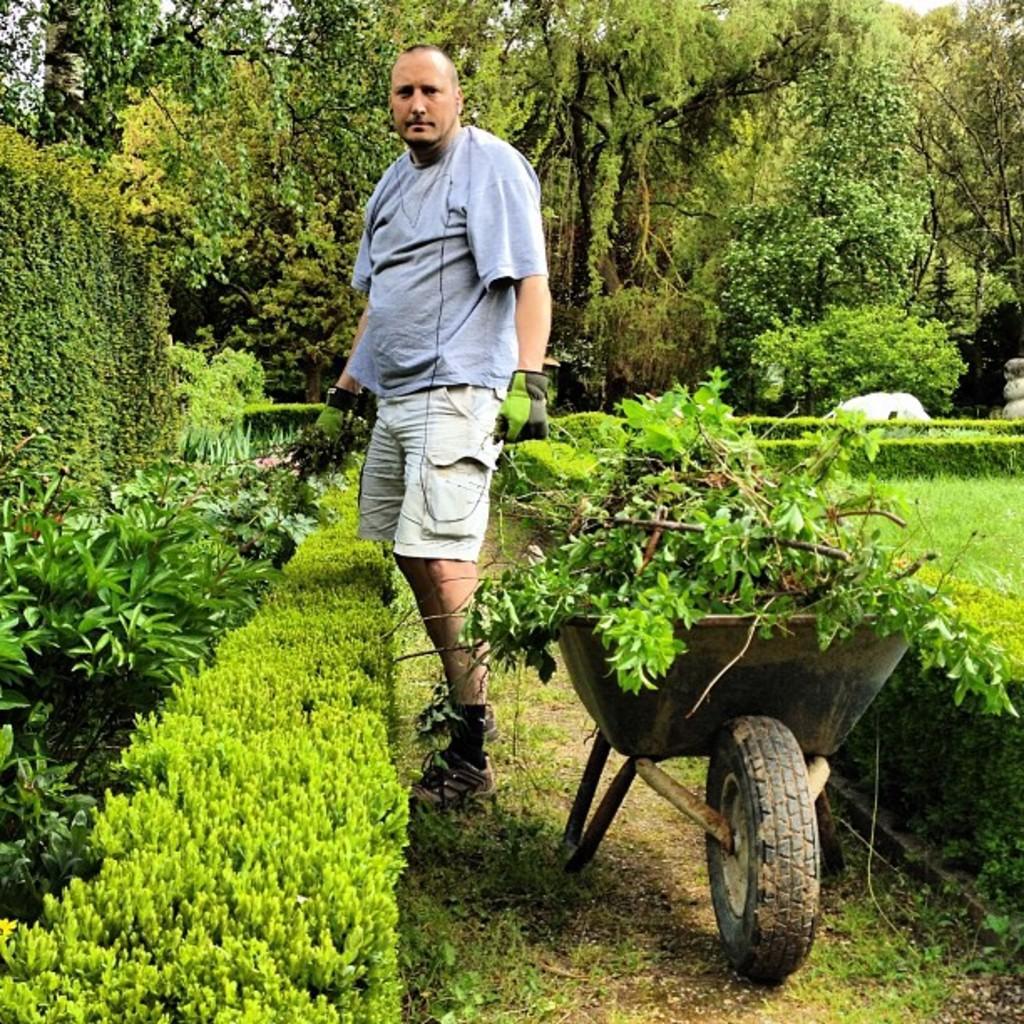In one or two sentences, can you explain what this image depicts? In the picture we can see garden with some path and on it we can see a cat and a man standing behind it, he is wearing a T-shirt, gloves and shoes and the garden is covered with grass, plants and trees. 